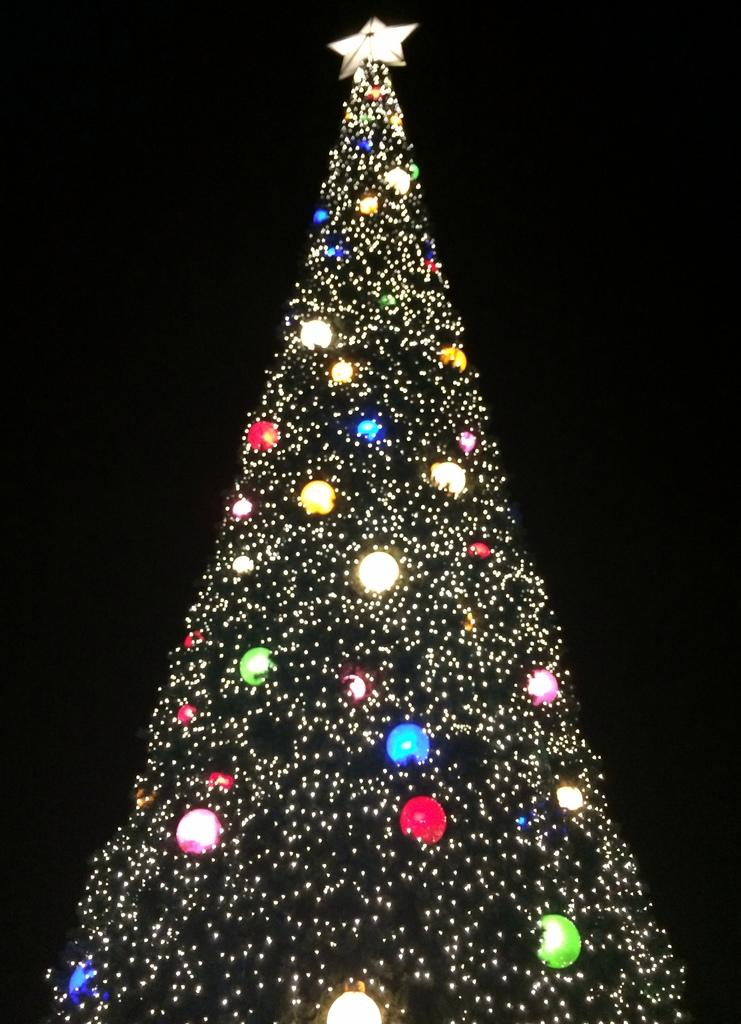What is the main subject of the image? There is a Xmas tree in the image. How is the Xmas tree decorated? The Xmas tree is made up of lights. What is at the top of the Xmas tree? There is a star at the top of the Xmas tree. What can be observed about the background of the image? The background of the image is dark. How many rabbits are sitting on the crate in the image? There are no rabbits or crates present in the image; it features a Xmas tree with lights and a star. 